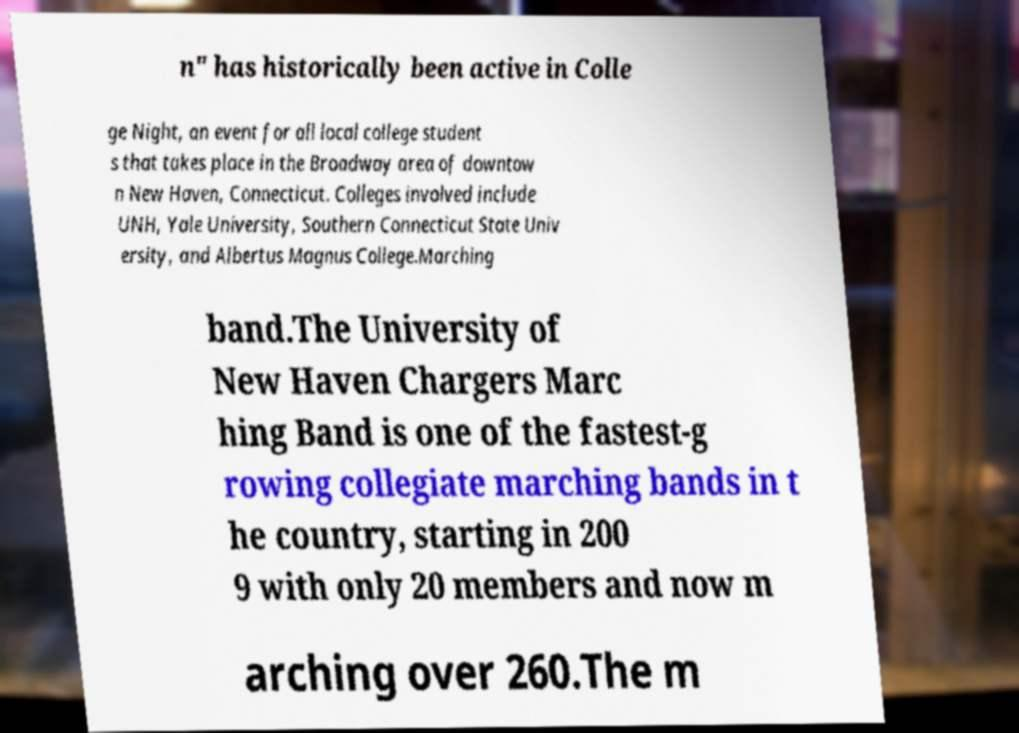There's text embedded in this image that I need extracted. Can you transcribe it verbatim? n" has historically been active in Colle ge Night, an event for all local college student s that takes place in the Broadway area of downtow n New Haven, Connecticut. Colleges involved include UNH, Yale University, Southern Connecticut State Univ ersity, and Albertus Magnus College.Marching band.The University of New Haven Chargers Marc hing Band is one of the fastest-g rowing collegiate marching bands in t he country, starting in 200 9 with only 20 members and now m arching over 260.The m 